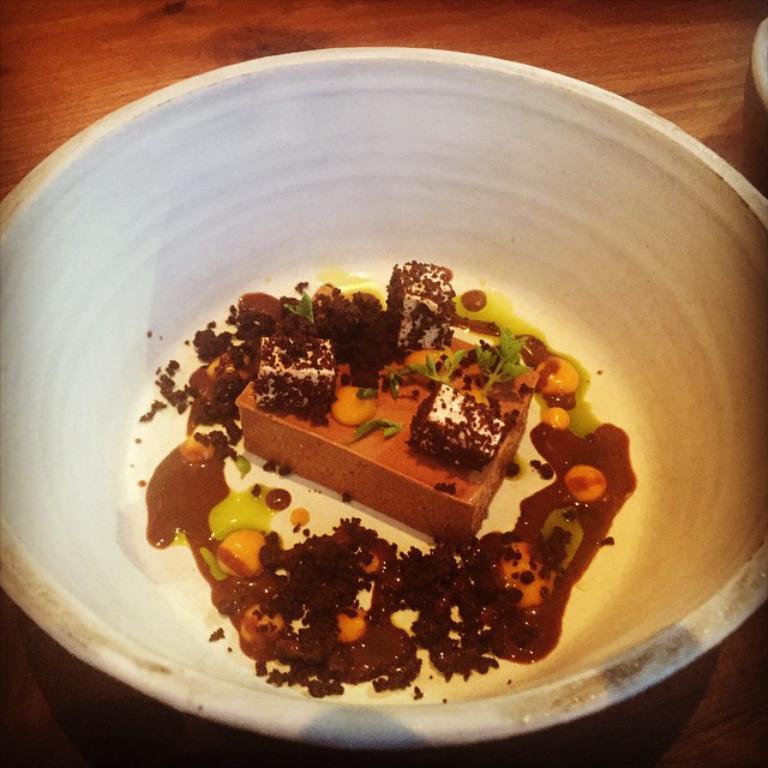Please provide a concise description of this image. In this picture I can see a food item in a bowl, on the table. 